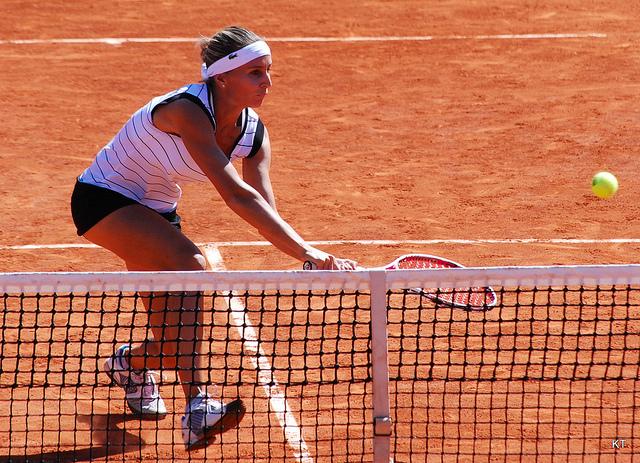What color is the ball?
Answer briefly. Yellow. What sport is the woman playing?
Be succinct. Tennis. Is this a man or woman?
Be succinct. Woman. 